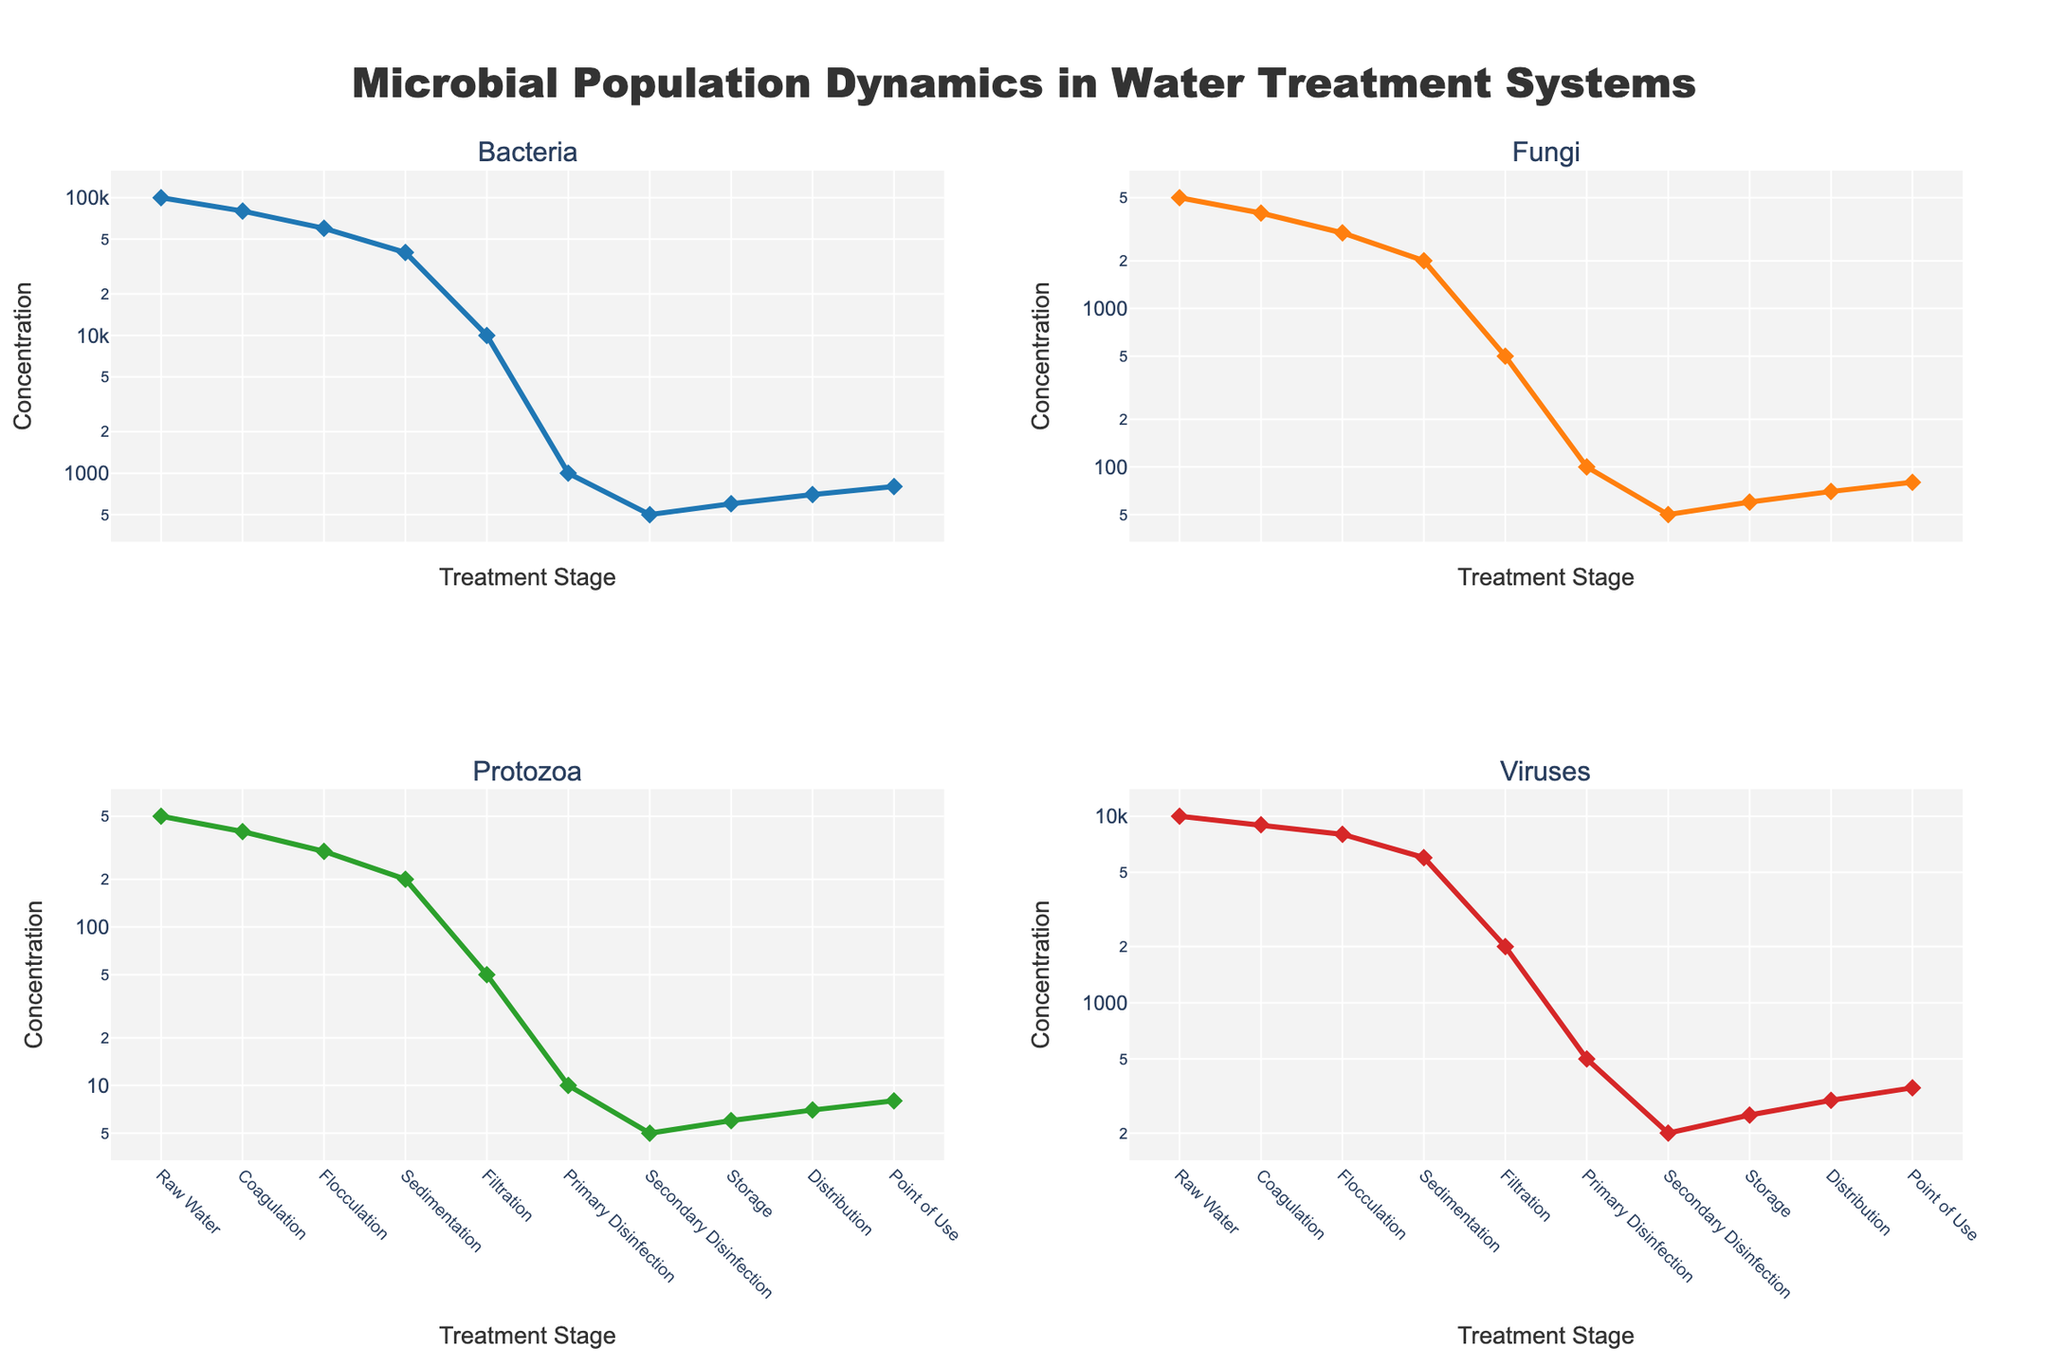What's the stage with the highest bacterial concentration? Refer to the Bacteria subplot. The highest value is at the "Raw Water" stage
Answer: Raw Water Which microbial group shows the largest decrease in concentration from Raw Water to Point of Use? Compare the concentration values of Bacteria, Fungi, Protozoa, and Viruses from "Raw Water" to "Point of Use". The biggest drop is observed in Bacteria (from 100,000 to 800)
Answer: Bacteria What's the difference in Protozoa concentration between Filtration and Distribution stages? Look at the Protozoa subplot. The Protozoa concentration at Filtration is 50 cells/L, and at Distribution, it is 7 cells/L. The difference is 50 - 7
Answer: 43 cells/L What's the average virus concentration across all treatment stages? Sum up the virus concentrations at all stages and divide by the number of stages: (10,000 + 9,000 + 8,000 + 6,000 + 2,000 + 500 + 200 + 250 + 300 + 350) / 10
Answer: 3,860 PFU/mL At which stage does Fungi concentration reduce by half compared to the previous stage? Observe the Fungi subplot. From Coagulation (4,000 CFU/mL) to Flocculation (3,000 CFU/mL), and from Flocculation to Sedimentation (2,000 CFU/mL), there isn't a halving. However, from Filtration (500) onward, the reduction reaches half from Primary Disinfection (100), so the answer is Primary Disinfection
Answer: Primary Disinfection Are there any stages where the concentration of any microorganism increases compared to the previous stage? Look closely at each subplot to compare stages. Between Storage and Distribution, all four types show slight increases
Answer: Yes, during Distribution for all types Which stage shows the smallest change in bacterial concentration compared to the previous stage? Identify the differences between each stage on the Bacteria subplot. The smallest change (-100) occurs from Secondary Disinfection (500 CFU/mL) to Storage (600 CFU/mL)
Answer: Storage How many stages does it take for viruses to drop below 1,000 PFU/mL? Viruses subplot shows 1,000 PFU/mL is reached between Primary and Secondary Disinfection stages. From Raw Water to Filtration, it remains above 1,000, but by Primary Disinfection, it falls significantly
Answer: 5 stages What's the ratio of Bacteria to Protozoa concentration in the Sedimentation stage? Sedimentation values are 40,000 CFU/mL (Bacteria) and 200 cells/L (Protozoa). Ratio = 40,000 / 200
Answer: 200 